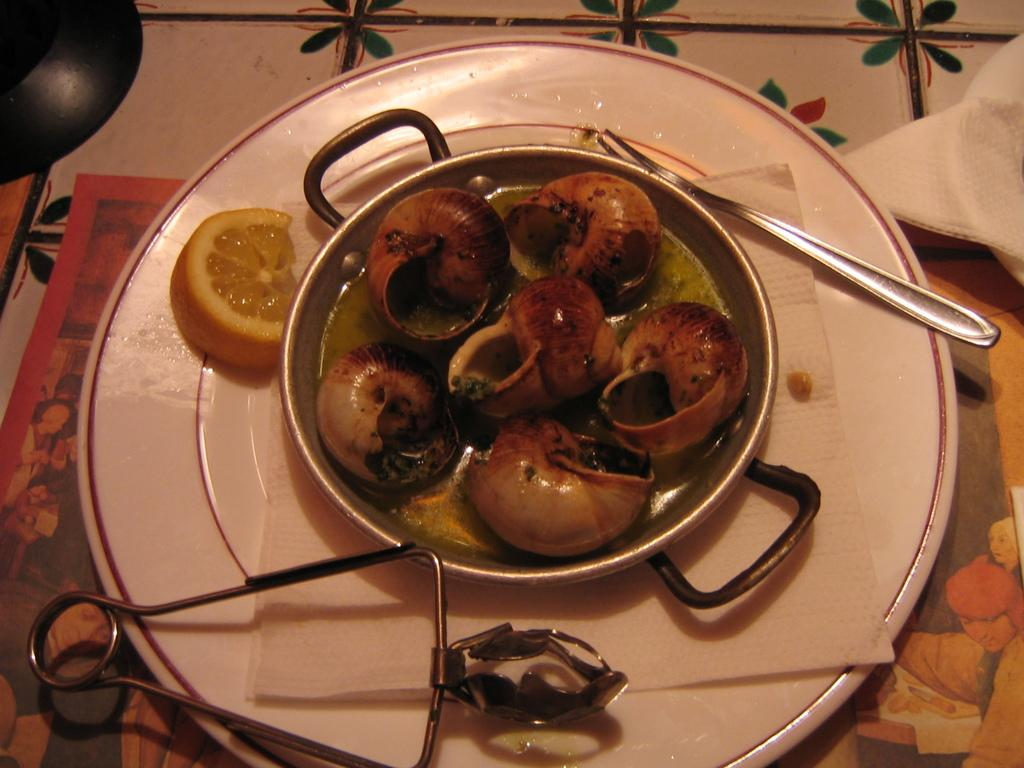What is in the dish that is visible in the image? There is food in a dish in the image. How is the dish arranged on the plate? The dish is placed on a plate in the image. Where is the plate located in the image? The plate is placed on a table in the image. What type of talk show is being filmed in the image? There is no talk show being filmed in the image; it only shows food in a dish, a dish on a plate, and a plate on a table. 